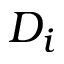<formula> <loc_0><loc_0><loc_500><loc_500>D _ { i }</formula> 